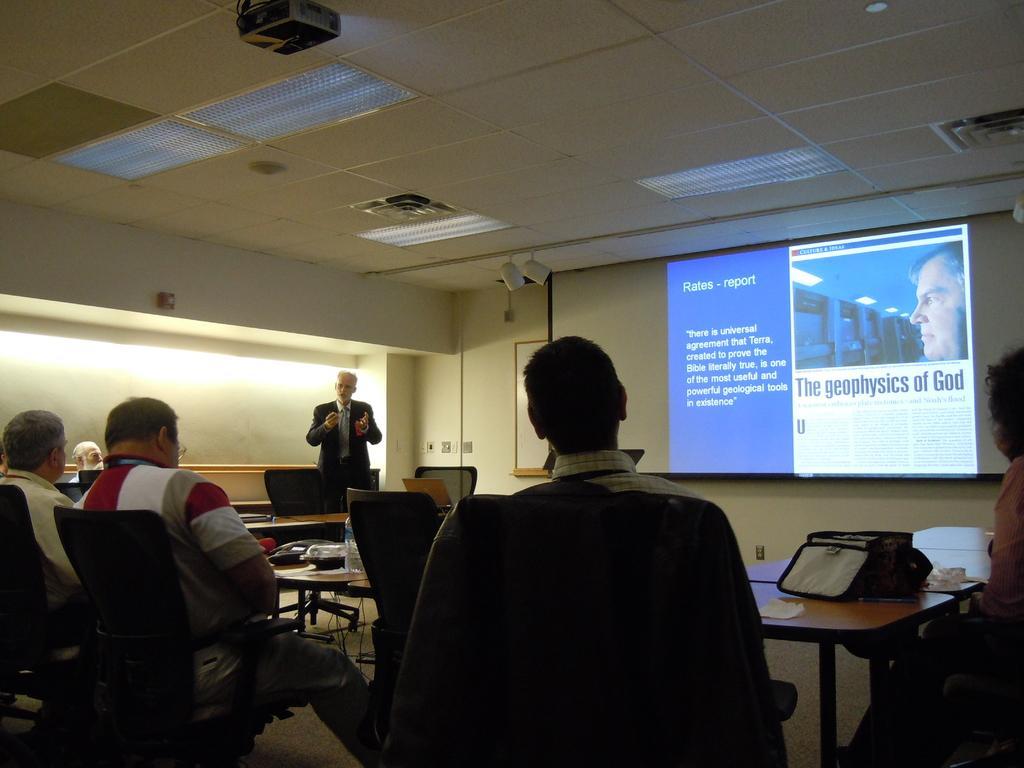Can you describe this image briefly? Here we can see a group of people sitting on chair and tables in front of them and in the middle we can see a man standing and giving a lecture and at the right side we can see a projector screen and at the top we can see a projector 